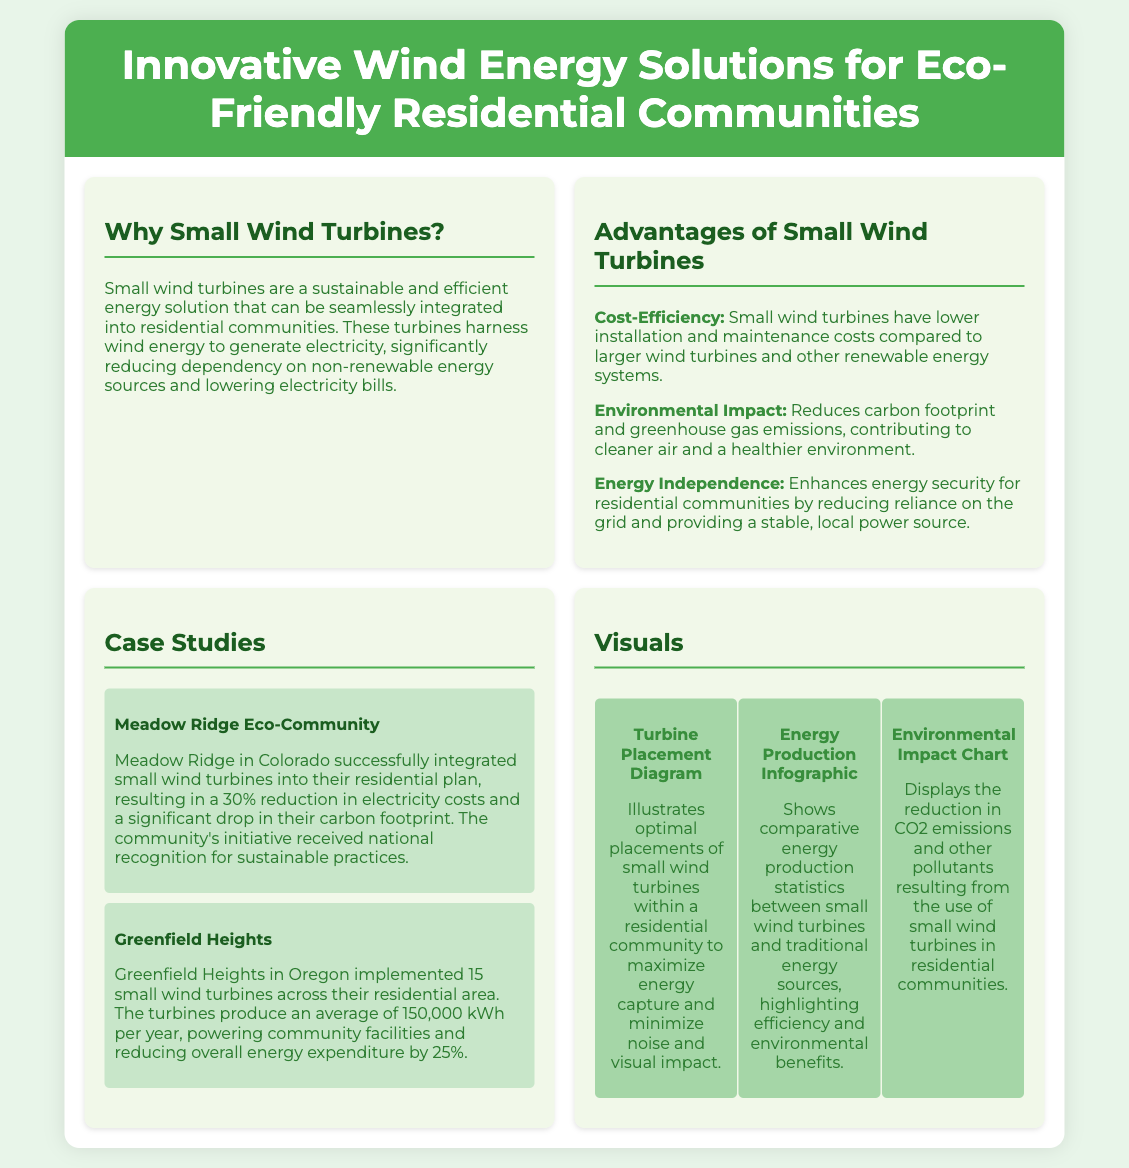What are small wind turbines used for? Small wind turbines harness wind energy to generate electricity for residential communities.
Answer: Generating electricity What is the average energy production of the small wind turbines in Greenfield Heights? The small wind turbines in Greenfield Heights produce an average of 150,000 kWh per year.
Answer: 150,000 kWh What percentage reduction in electricity costs did Meadow Ridge Eco-Community achieve? Meadow Ridge achieved a 30% reduction in electricity costs.
Answer: 30% Which community received national recognition for sustainable practices? Meadow Ridge in Colorado received national recognition for sustainable practices.
Answer: Meadow Ridge What is one of the key advantages of small wind turbines mentioned in the flyer? Cost-efficiency is one of the key advantages mentioned in the flyer.
Answer: Cost-efficiency How many small wind turbines were implemented in Greenfield Heights? Greenfield Heights implemented 15 small wind turbines across their residential area.
Answer: 15 What type of diagram is included in the visuals section? The visuals section includes a turbine placement diagram.
Answer: Turbine Placement Diagram What environmental benefit do small wind turbines reduce? Small wind turbines reduce carbon footprint and greenhouse gas emissions.
Answer: Carbon footprint 